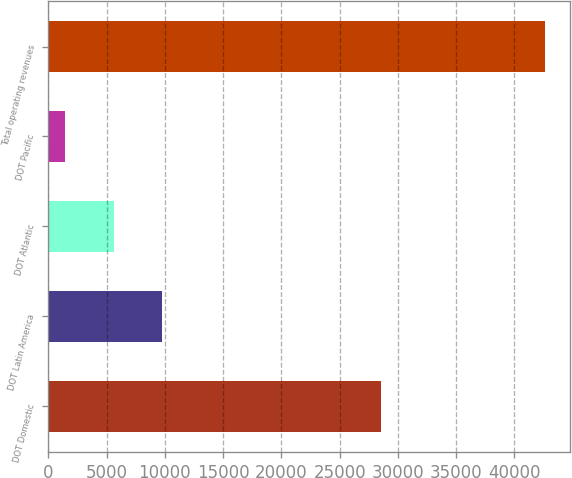Convert chart to OTSL. <chart><loc_0><loc_0><loc_500><loc_500><bar_chart><fcel>DOT Domestic<fcel>DOT Latin America<fcel>DOT Atlantic<fcel>DOT Pacific<fcel>Total operating revenues<nl><fcel>28568<fcel>9770.4<fcel>5652<fcel>1466<fcel>42650<nl></chart> 